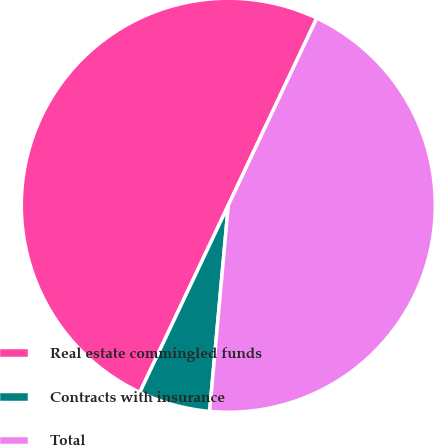<chart> <loc_0><loc_0><loc_500><loc_500><pie_chart><fcel>Real estate commingled funds<fcel>Contracts with insurance<fcel>Total<nl><fcel>50.0%<fcel>5.59%<fcel>44.41%<nl></chart> 